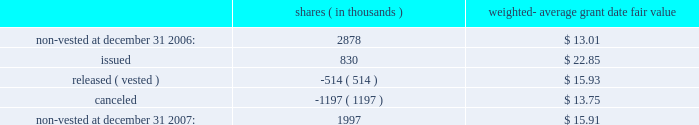Prior to its adoption of sfas no .
123 ( r ) , the company recorded compensation expense for restricted stock awards on a straight-line basis over their vesting period .
If an employee forfeited the award prior to vesting , the company reversed out the previously expensed amounts in the period of forfeiture .
As required upon adoption of sfas no .
123 ( r ) , the company must base its accruals of compensation expense on the estimated number of awards for which the requisite service period is expected to be rendered .
Actual forfeitures are no longer recorded in the period of forfeiture .
In 2005 , the company recorded a pre-tax credit of $ 2.8 million in cumulative effect of accounting change , that represents the amount by which compensation expense would have been reduced in periods prior to adoption of sfas no .
123 ( r ) for restricted stock awards outstanding on july 1 , 2005 that are anticipated to be forfeited .
A summary of non-vested restricted stock award and restricted stock unit activity is presented below : shares ( in thousands ) weighted- average date fair .
As of december 31 , 2007 , there was $ 15.3 million of total unrecognized compensation cost related to non-vested awards .
This cost is expected to be recognized over a weighted-average period of 1.6 years .
The total fair value of restricted shares and restricted stock units vested was $ 11.0 million , $ 7.5 million and $ 4.1 million for the years ended december 31 , 2007 , 2006 and 2005 , respectively .
Employee stock purchase plan the shareholders of the company previously approved the 2002 employee stock purchase plan ( 201c2002 purchase plan 201d ) , and reserved 5000000 shares of common stock for sale to employees at a price no less than 85% ( 85 % ) of the lower of the fair market value of the common stock at the beginning of the one-year offering period or the end of each of the six-month purchase periods .
Under sfas no .
123 ( r ) , the 2002 purchase plan was considered compensatory .
Effective august 1 , 2005 , the company changed the terms of its purchase plan to reduce the discount to 5% ( 5 % ) and discontinued the look-back provision .
As a result , the purchase plan was not compensatory beginning august 1 , 2005 .
For the year ended december 31 , 2005 , the company recorded $ 0.4 million in compensation expense for its employee stock purchase plan for the period in which the 2002 plan was considered compensatory until the terms were changed august 1 , 2005 .
At december 31 , 2007 , 757123 shares were available for purchase under the 2002 purchase plan .
401 ( k ) plan the company has a 401 ( k ) salary deferral program for eligible employees who have met certain service requirements .
The company matches certain employee contributions ; additional contributions to this plan are at the discretion of the company .
Total contribution expense under this plan was $ 5.7 million , $ 5.7 million and $ 5.2 million for the years ended december 31 , 2007 , 2006 and 2005 , respectively. .
As of december 31 2006 what was the ratio of the non-vested to the shares issued? 
Rationale: as of december 31 2006 there was 3.47 shares of the non-vested to the shares issued
Computations: (2878 / 830)
Answer: 3.46747. 